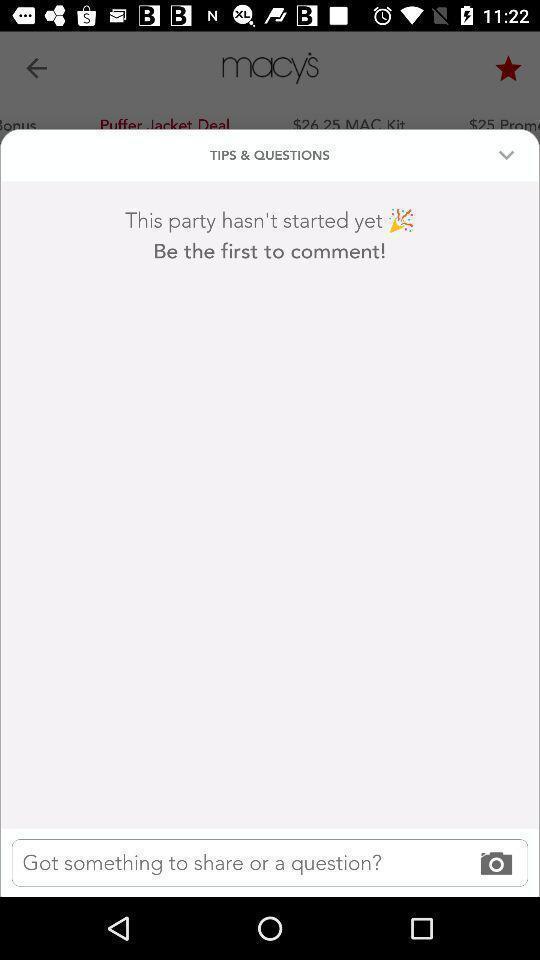Describe this image in words. Popup of the page to ask questions in the application. 